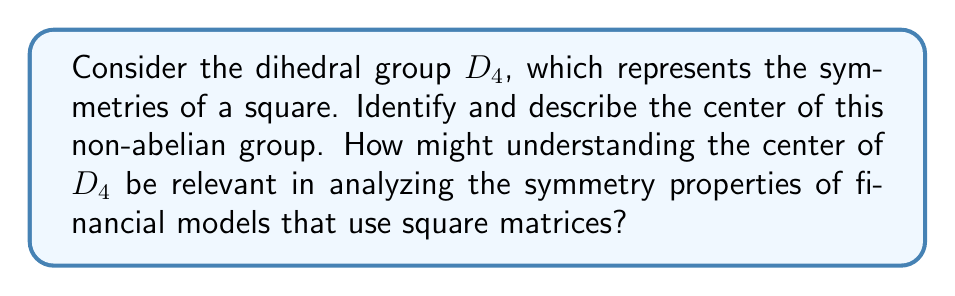What is the answer to this math problem? Let's approach this step-by-step:

1) First, recall that $D_4$ is a non-abelian group of order 8, consisting of 4 rotations and 4 reflections of a square.

2) The elements of $D_4$ are:
   - Identity (e)
   - Rotations: 90° ($r$), 180° ($r^2$), 270° ($r^3$)
   - Reflections: horizontal ($h$), vertical ($v$), diagonal ($d_1$), anti-diagonal ($d_2$)

3) The center of a group $G$, denoted $Z(G)$, is the set of all elements that commute with every element in $G$. In other words:

   $Z(G) = \{a \in G : ax = xa \text{ for all } x \in G\}$

4) To find the center, we need to check which elements commute with all others:

   - The identity $e$ always commutes with all elements.
   - $r^2$ (180° rotation) commutes with all elements because it's equivalent to two consecutive applications of any reflection.
   - All other elements don't commute with at least one other element.

5) Therefore, the center of $D_4$ is $Z(D_4) = \{e, r^2\}$.

Relevance to Finance:
In financial modeling, square matrices are often used to represent covariance or correlation matrices in portfolio theory, or transition matrices in Markov processes. Understanding the center of $D_4$ can provide insights into invariant properties of these matrices under certain transformations. For instance, operations that correspond to elements in the center ($e$ and $r^2$) will preserve the structure of these matrices in ways that other symmetry operations might not.
Answer: The center of the dihedral group $D_4$ is $Z(D_4) = \{e, r^2\}$, where $e$ is the identity element and $r^2$ represents a 180° rotation. 